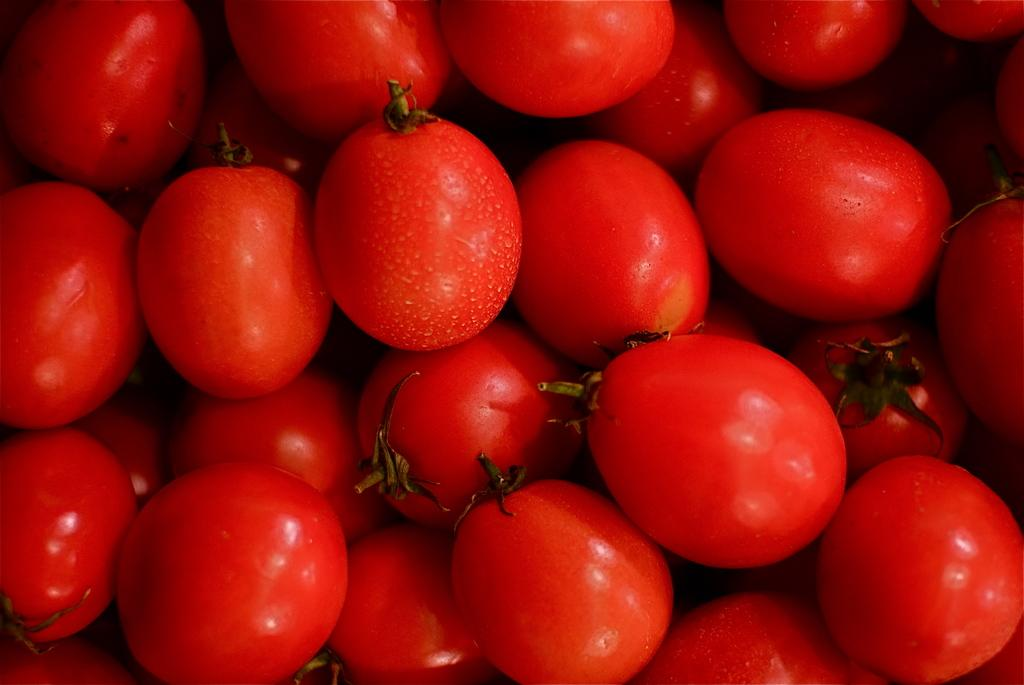What type of food can be seen in the image? A: There are fruits in the image. What color are the fruits? The fruits are red in color. What other elements are present in the image besides the fruits? There are green leaves in the image. Where are the green leaves located in relation to the fruits? The green leaves are located above the fruits. How many jellyfish can be seen swimming on the sidewalk in the picture? There are no jellyfish or sidewalks present in the image; it features fruits and green leaves. 